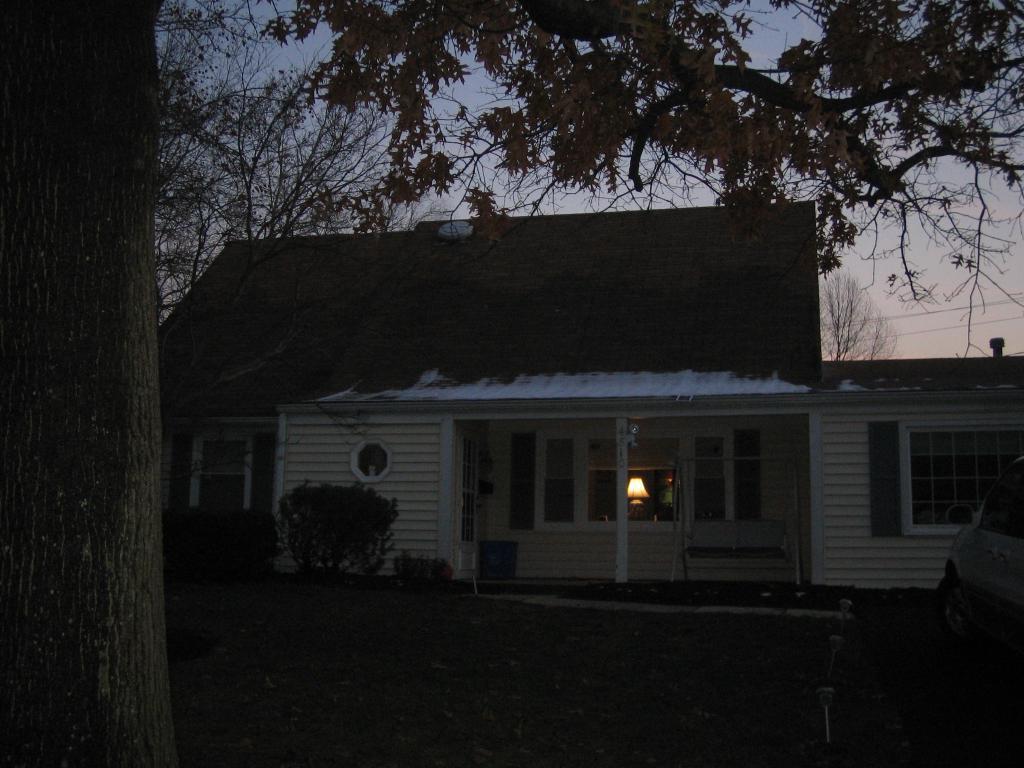How would you summarize this image in a sentence or two? In this image on the left side we can see a tree trunk and on the right side there is a vehicle on the ground. In the background we can see a house, windows, doors, lamp, plants, roof, branches of a tree, trees, wires and clouds in the sky. 